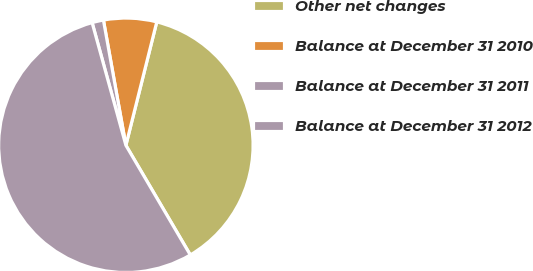Convert chart. <chart><loc_0><loc_0><loc_500><loc_500><pie_chart><fcel>Other net changes<fcel>Balance at December 31 2010<fcel>Balance at December 31 2011<fcel>Balance at December 31 2012<nl><fcel>37.64%<fcel>6.73%<fcel>1.45%<fcel>54.18%<nl></chart> 